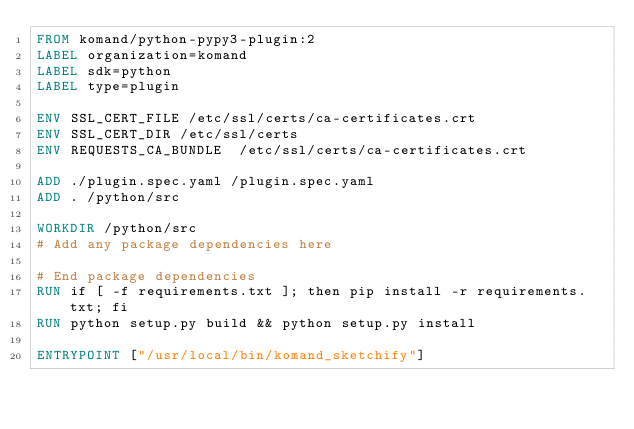<code> <loc_0><loc_0><loc_500><loc_500><_Dockerfile_>FROM komand/python-pypy3-plugin:2
LABEL organization=komand
LABEL sdk=python
LABEL type=plugin

ENV SSL_CERT_FILE /etc/ssl/certs/ca-certificates.crt
ENV SSL_CERT_DIR /etc/ssl/certs
ENV REQUESTS_CA_BUNDLE  /etc/ssl/certs/ca-certificates.crt

ADD ./plugin.spec.yaml /plugin.spec.yaml
ADD . /python/src

WORKDIR /python/src
# Add any package dependencies here

# End package dependencies
RUN if [ -f requirements.txt ]; then pip install -r requirements.txt; fi
RUN python setup.py build && python setup.py install

ENTRYPOINT ["/usr/local/bin/komand_sketchify"]</code> 